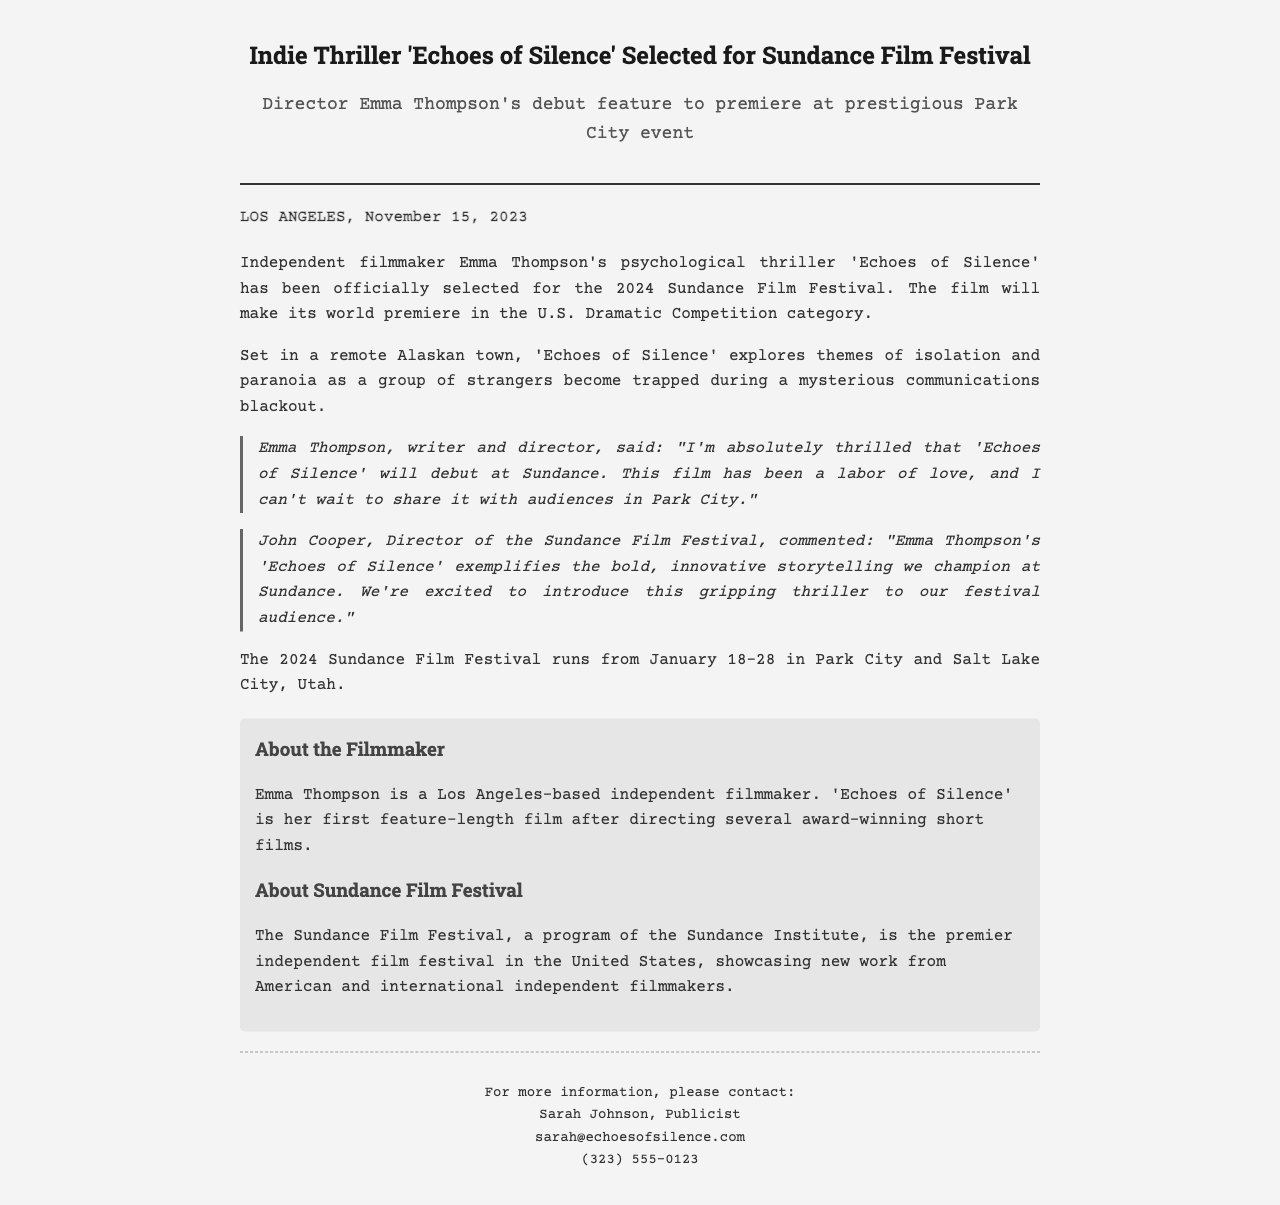What is the title of the film? The title of the film is mentioned at the beginning of the document.
Answer: Echoes of Silence Who is the director of the film? The director’s name is stated in the first paragraph of the document.
Answer: Emma Thompson What category is the film competing in at Sundance? The document specifies the competition category for the film.
Answer: U.S. Dramatic Competition When will the Sundance Film Festival take place? The dates of the festival are provided towards the end of the document.
Answer: January 18-28 What is the main theme of 'Echoes of Silence'? The document discusses the themes explored in the film.
Answer: Isolation and paranoia Who commented about the film's selection from the Sundance Film Festival? The document includes a quote from a festival organizer about the film.
Answer: John Cooper What is Emma Thompson's previous work before this film? The about section hints at her experience prior to this feature-length film.
Answer: Several award-winning short films What is the location setting of the film? The document provides information about where the film is set.
Answer: A remote Alaskan town Who is the publicist for the film? The contact information section lists the publicist's name.
Answer: Sarah Johnson 